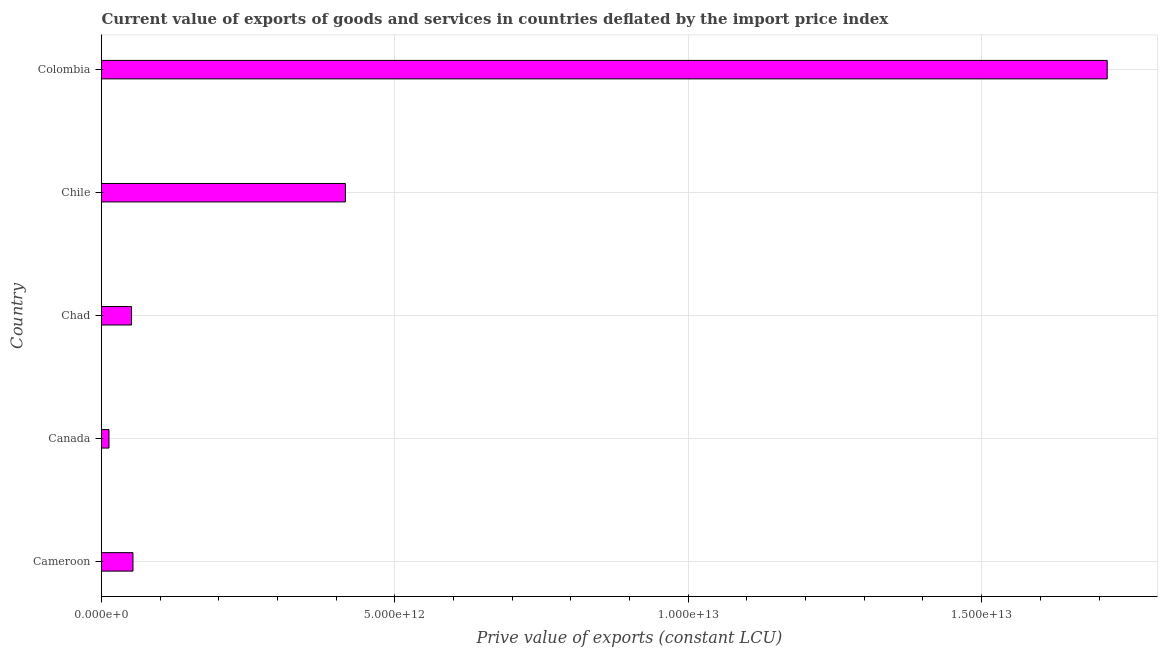What is the title of the graph?
Your answer should be very brief. Current value of exports of goods and services in countries deflated by the import price index. What is the label or title of the X-axis?
Your response must be concise. Prive value of exports (constant LCU). What is the price value of exports in Colombia?
Provide a succinct answer. 1.71e+13. Across all countries, what is the maximum price value of exports?
Provide a short and direct response. 1.71e+13. Across all countries, what is the minimum price value of exports?
Offer a terse response. 1.28e+11. In which country was the price value of exports maximum?
Your answer should be very brief. Colombia. What is the sum of the price value of exports?
Your answer should be very brief. 2.25e+13. What is the difference between the price value of exports in Chad and Chile?
Make the answer very short. -3.65e+12. What is the average price value of exports per country?
Provide a succinct answer. 4.49e+12. What is the median price value of exports?
Your answer should be compact. 5.36e+11. What is the ratio of the price value of exports in Canada to that in Chad?
Provide a short and direct response. 0.25. Is the price value of exports in Chad less than that in Colombia?
Offer a terse response. Yes. What is the difference between the highest and the second highest price value of exports?
Keep it short and to the point. 1.30e+13. What is the difference between the highest and the lowest price value of exports?
Ensure brevity in your answer.  1.70e+13. Are all the bars in the graph horizontal?
Keep it short and to the point. Yes. How many countries are there in the graph?
Your answer should be compact. 5. What is the difference between two consecutive major ticks on the X-axis?
Keep it short and to the point. 5.00e+12. What is the Prive value of exports (constant LCU) in Cameroon?
Make the answer very short. 5.36e+11. What is the Prive value of exports (constant LCU) in Canada?
Offer a terse response. 1.28e+11. What is the Prive value of exports (constant LCU) of Chad?
Offer a terse response. 5.12e+11. What is the Prive value of exports (constant LCU) of Chile?
Provide a short and direct response. 4.16e+12. What is the Prive value of exports (constant LCU) in Colombia?
Make the answer very short. 1.71e+13. What is the difference between the Prive value of exports (constant LCU) in Cameroon and Canada?
Keep it short and to the point. 4.08e+11. What is the difference between the Prive value of exports (constant LCU) in Cameroon and Chad?
Your response must be concise. 2.42e+1. What is the difference between the Prive value of exports (constant LCU) in Cameroon and Chile?
Your response must be concise. -3.62e+12. What is the difference between the Prive value of exports (constant LCU) in Cameroon and Colombia?
Provide a short and direct response. -1.66e+13. What is the difference between the Prive value of exports (constant LCU) in Canada and Chad?
Your answer should be compact. -3.84e+11. What is the difference between the Prive value of exports (constant LCU) in Canada and Chile?
Give a very brief answer. -4.03e+12. What is the difference between the Prive value of exports (constant LCU) in Canada and Colombia?
Give a very brief answer. -1.70e+13. What is the difference between the Prive value of exports (constant LCU) in Chad and Chile?
Keep it short and to the point. -3.65e+12. What is the difference between the Prive value of exports (constant LCU) in Chad and Colombia?
Make the answer very short. -1.66e+13. What is the difference between the Prive value of exports (constant LCU) in Chile and Colombia?
Offer a terse response. -1.30e+13. What is the ratio of the Prive value of exports (constant LCU) in Cameroon to that in Canada?
Keep it short and to the point. 4.2. What is the ratio of the Prive value of exports (constant LCU) in Cameroon to that in Chad?
Ensure brevity in your answer.  1.05. What is the ratio of the Prive value of exports (constant LCU) in Cameroon to that in Chile?
Give a very brief answer. 0.13. What is the ratio of the Prive value of exports (constant LCU) in Cameroon to that in Colombia?
Provide a short and direct response. 0.03. What is the ratio of the Prive value of exports (constant LCU) in Canada to that in Chad?
Your answer should be compact. 0.25. What is the ratio of the Prive value of exports (constant LCU) in Canada to that in Chile?
Your answer should be very brief. 0.03. What is the ratio of the Prive value of exports (constant LCU) in Canada to that in Colombia?
Offer a very short reply. 0.01. What is the ratio of the Prive value of exports (constant LCU) in Chad to that in Chile?
Offer a very short reply. 0.12. What is the ratio of the Prive value of exports (constant LCU) in Chile to that in Colombia?
Your response must be concise. 0.24. 